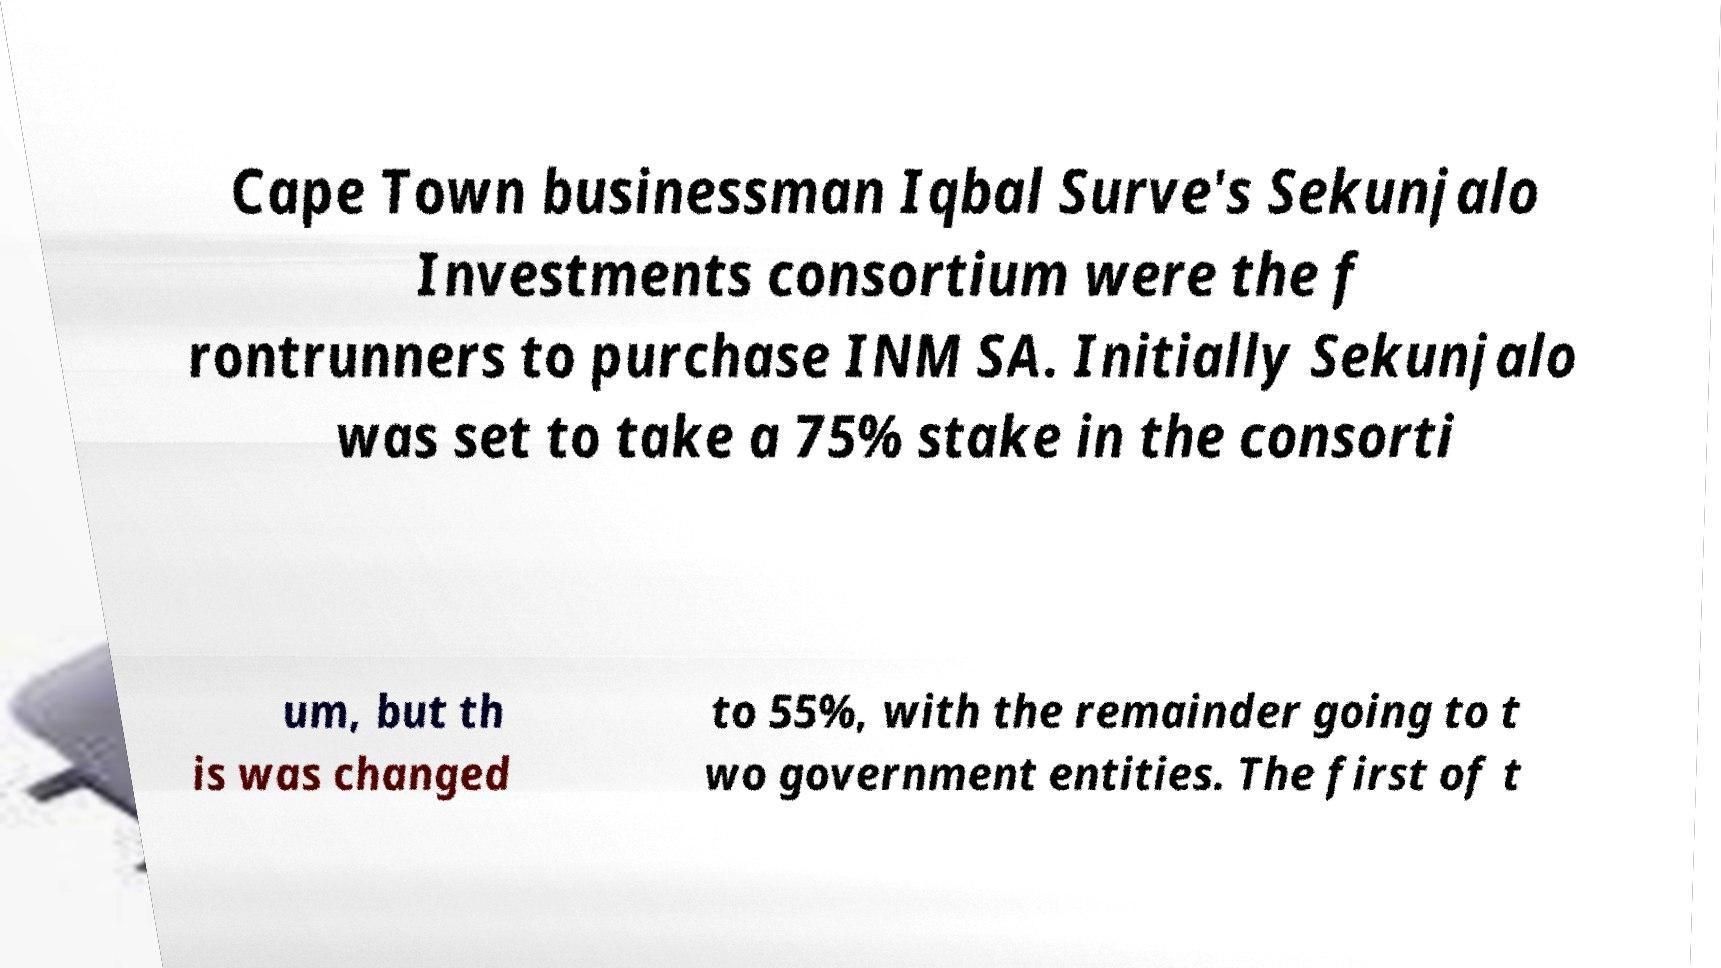There's text embedded in this image that I need extracted. Can you transcribe it verbatim? Cape Town businessman Iqbal Surve's Sekunjalo Investments consortium were the f rontrunners to purchase INM SA. Initially Sekunjalo was set to take a 75% stake in the consorti um, but th is was changed to 55%, with the remainder going to t wo government entities. The first of t 